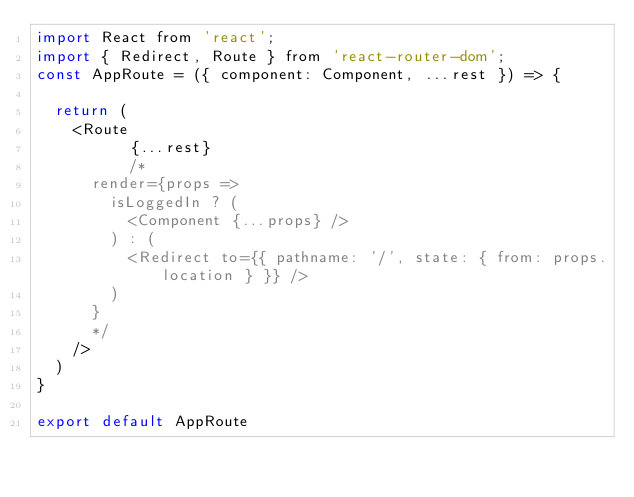<code> <loc_0><loc_0><loc_500><loc_500><_JavaScript_>import React from 'react';
import { Redirect, Route } from 'react-router-dom';
const AppRoute = ({ component: Component, ...rest }) => {

  return (
    <Route
          {...rest}
          /*
      render={props =>
        isLoggedIn ? (
          <Component {...props} />
        ) : (
          <Redirect to={{ pathname: '/', state: { from: props.location } }} />
        )
      }
      */
    />
  )
}

export default AppRoute</code> 